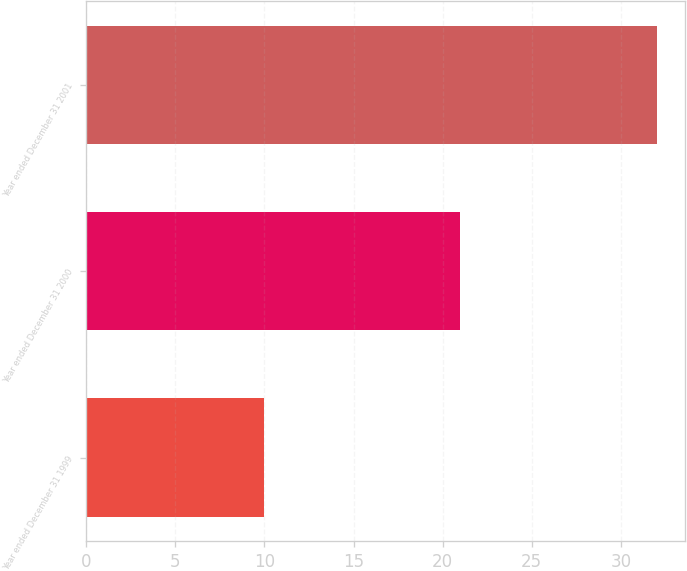Convert chart. <chart><loc_0><loc_0><loc_500><loc_500><bar_chart><fcel>Year ended December 31 1999<fcel>Year ended December 31 2000<fcel>Year ended December 31 2001<nl><fcel>10<fcel>21<fcel>32<nl></chart> 